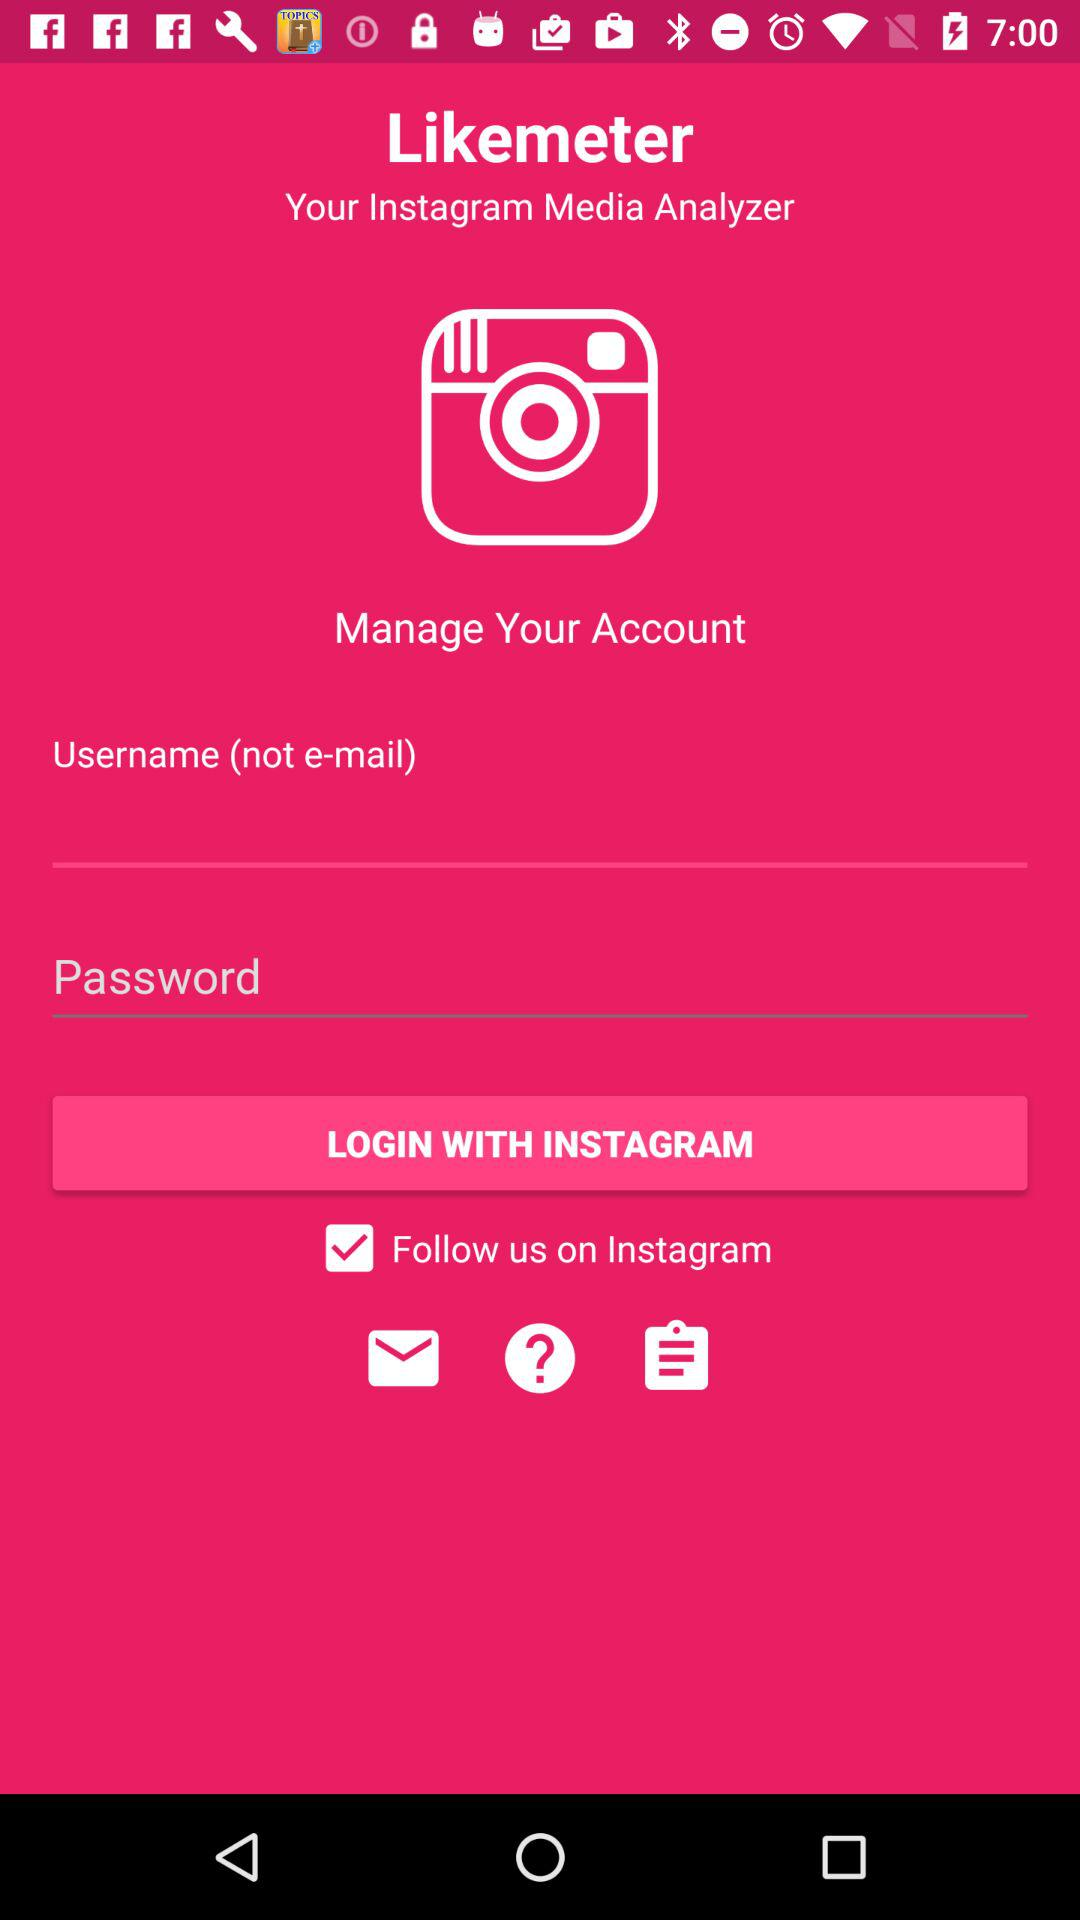How many login fields are there?
Answer the question using a single word or phrase. 2 